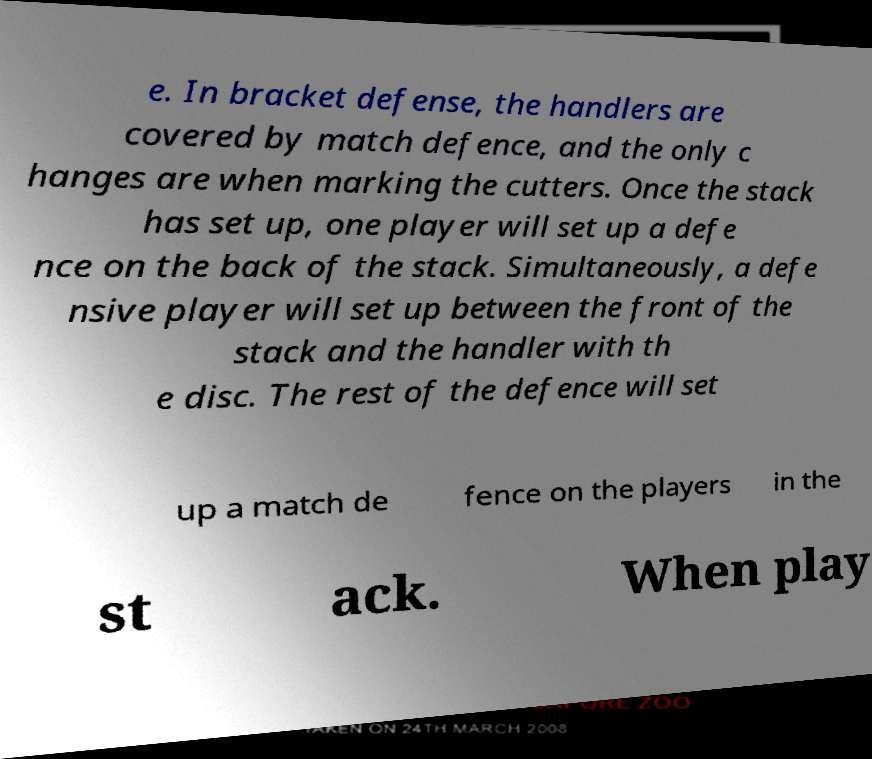Can you read and provide the text displayed in the image?This photo seems to have some interesting text. Can you extract and type it out for me? e. In bracket defense, the handlers are covered by match defence, and the only c hanges are when marking the cutters. Once the stack has set up, one player will set up a defe nce on the back of the stack. Simultaneously, a defe nsive player will set up between the front of the stack and the handler with th e disc. The rest of the defence will set up a match de fence on the players in the st ack. When play 